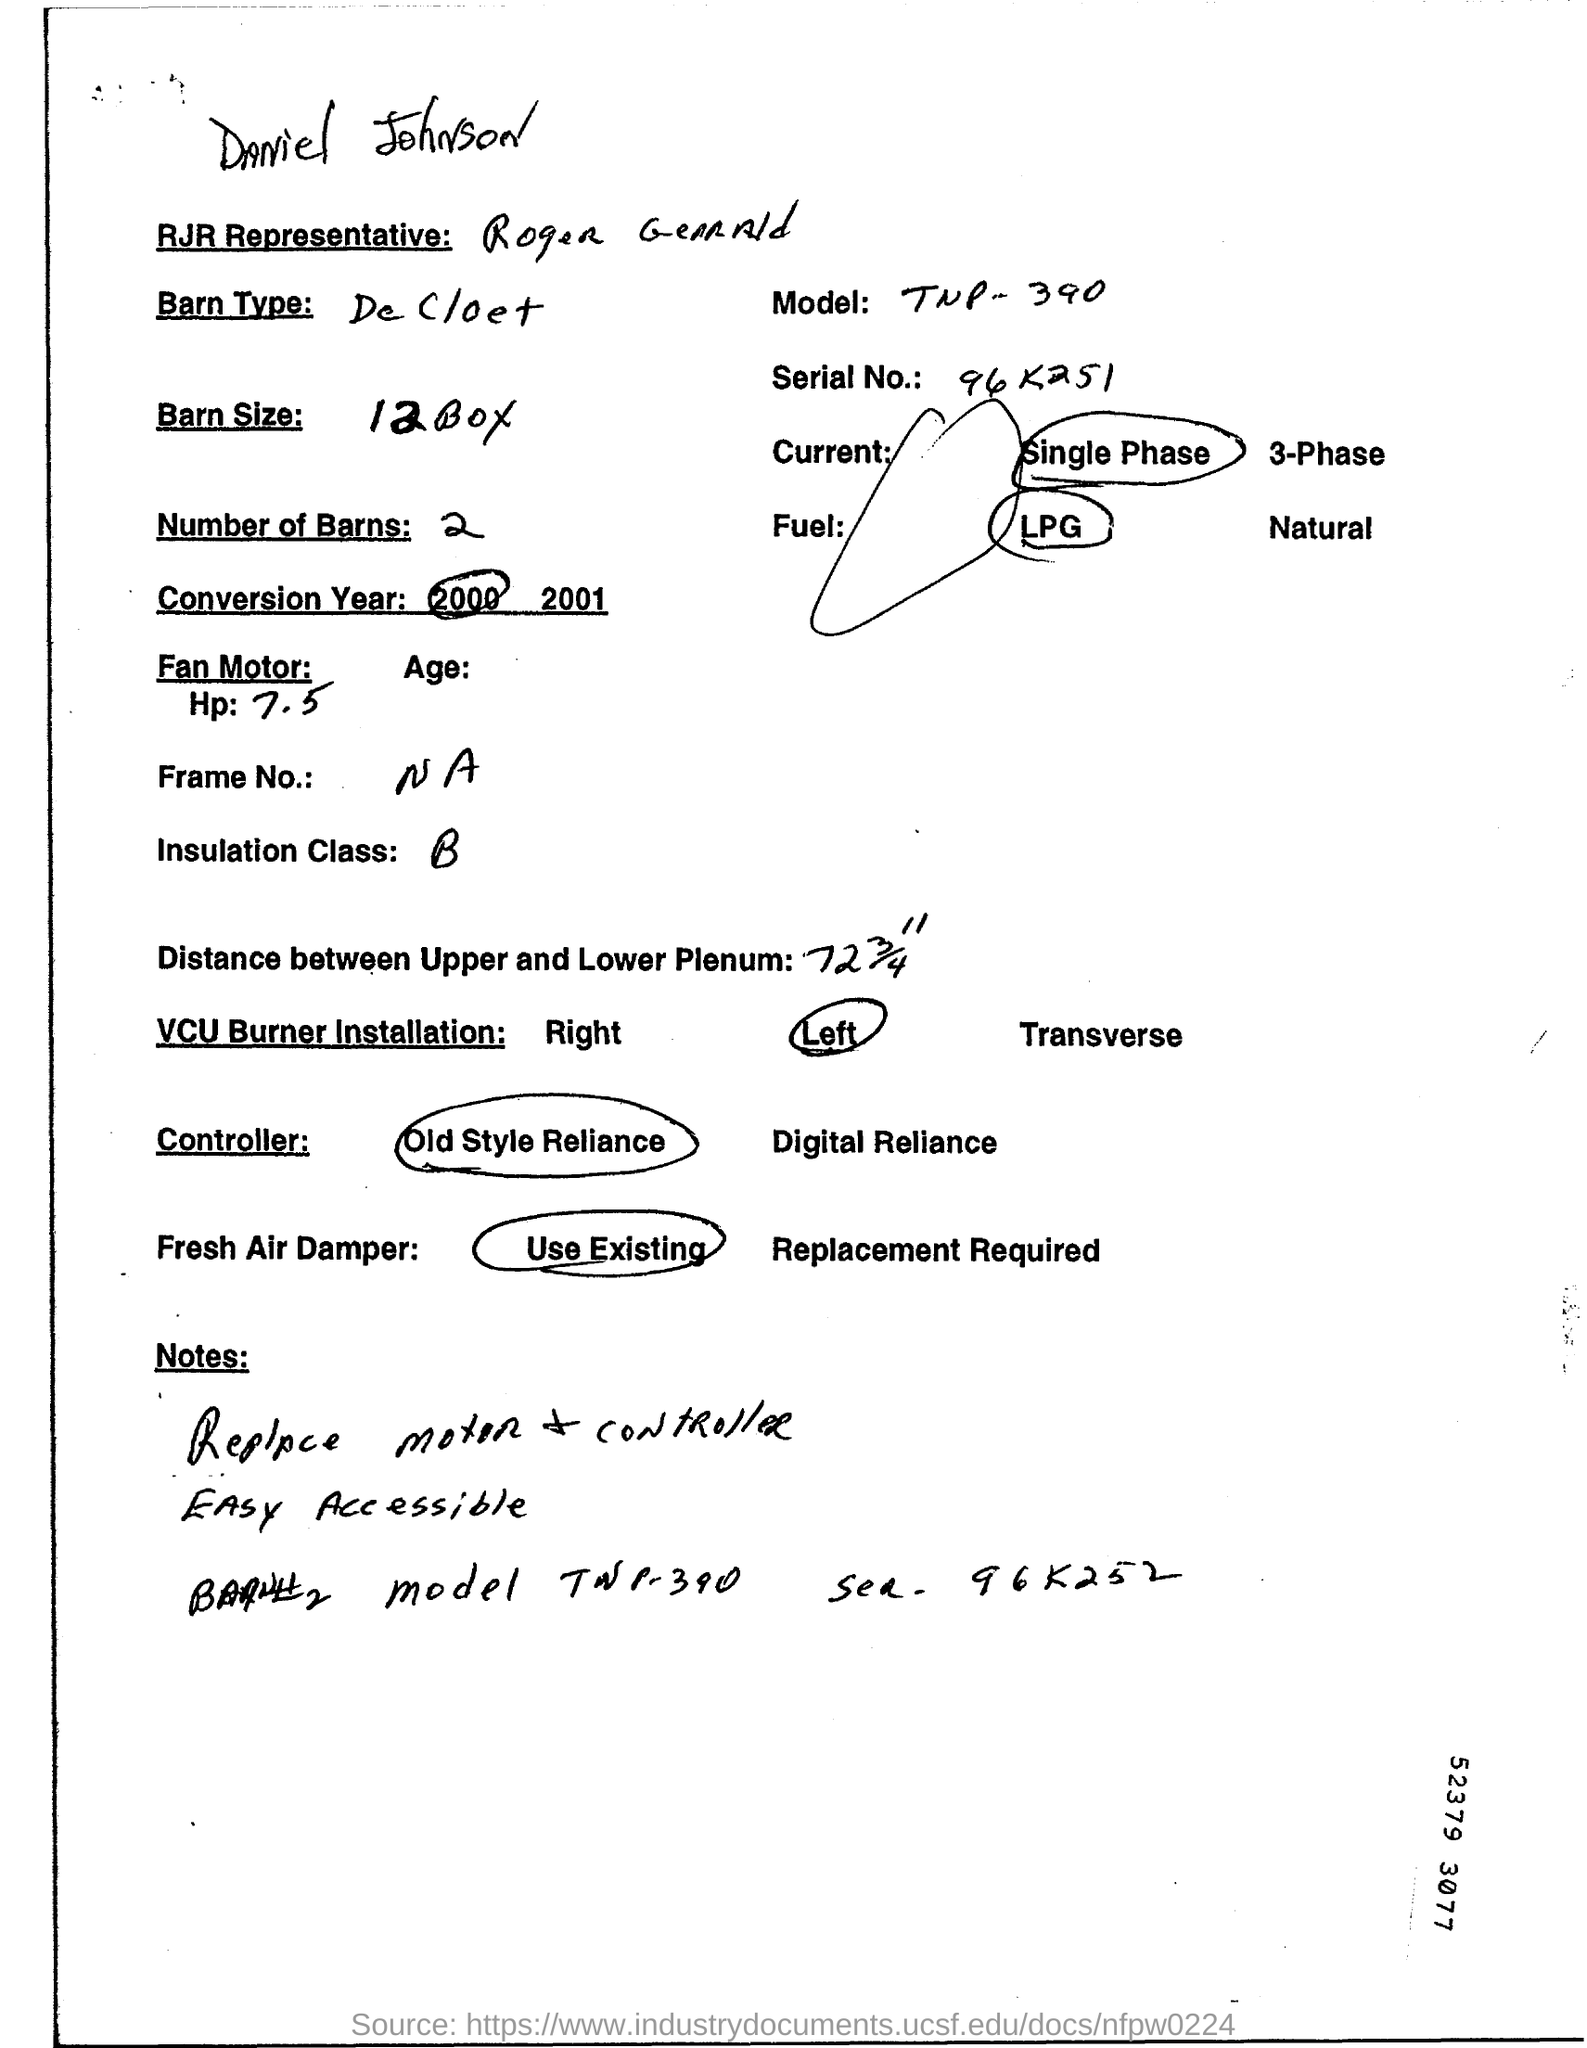What is the Serial No. mentioned in the document?
Provide a short and direct response. 96 K251. 